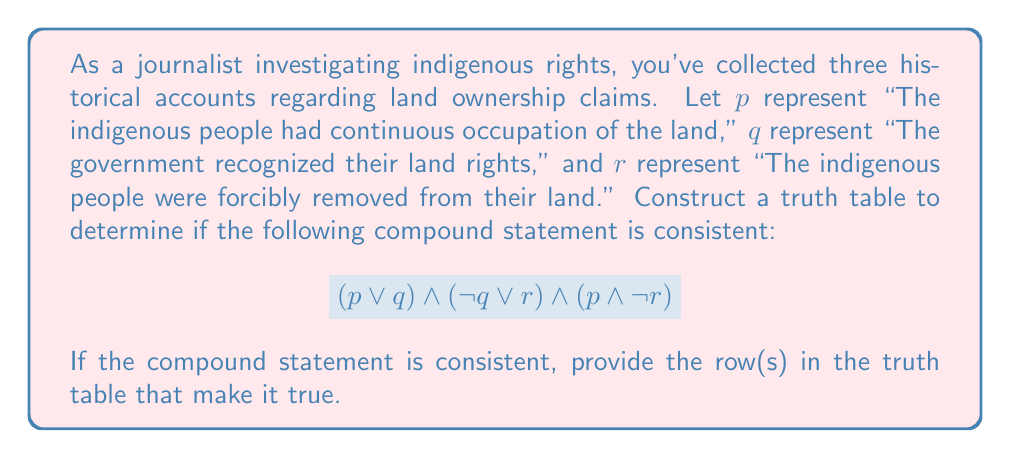Give your solution to this math problem. To evaluate the consistency of the compound statement, we need to construct a truth table and check if there's at least one row where the entire statement is true.

Step 1: Identify the atomic propositions and create the truth table columns.
p, q, r

Step 2: Create columns for each part of the compound statement.
$(p \lor q)$, $(\neg q \lor r)$, $(p \land \neg r)$

Step 3: Create a final column for the entire compound statement.
$(p \lor q) \land (\neg q \lor r) \land (p \land \neg r)$

Step 4: Complete the truth table.

$$\begin{array}{|c|c|c|c|c|c|c|}
\hline
p & q & r & (p \lor q) & (\neg q \lor r) & (p \land \neg r) & (p \lor q) \land (\neg q \lor r) \land (p \land \neg r) \\
\hline
T & T & T & T & T & F & F \\
T & T & F & T & F & T & F \\
T & F & T & T & T & F & F \\
T & F & F & T & T & T & T \\
F & T & T & T & T & F & F \\
F & T & F & T & F & F & F \\
F & F & T & F & T & F & F \\
F & F & F & F & T & F & F \\
\hline
\end{array}$$

Step 5: Analyze the results.
The compound statement is true in one row of the truth table (p = T, q = F, r = F). This means the statement is consistent.

Step 6: Interpret the result in the context of the historical accounts.
The consistent scenario suggests that:
- The indigenous people had continuous occupation of the land (p = T)
- The government did not recognize their land rights (q = F)
- The indigenous people were not forcibly removed from their land (r = F)

This combination of truth values satisfies all parts of the compound statement, indicating a possible historical scenario that aligns with the given claims.
Answer: Consistent; (T, F, F) 